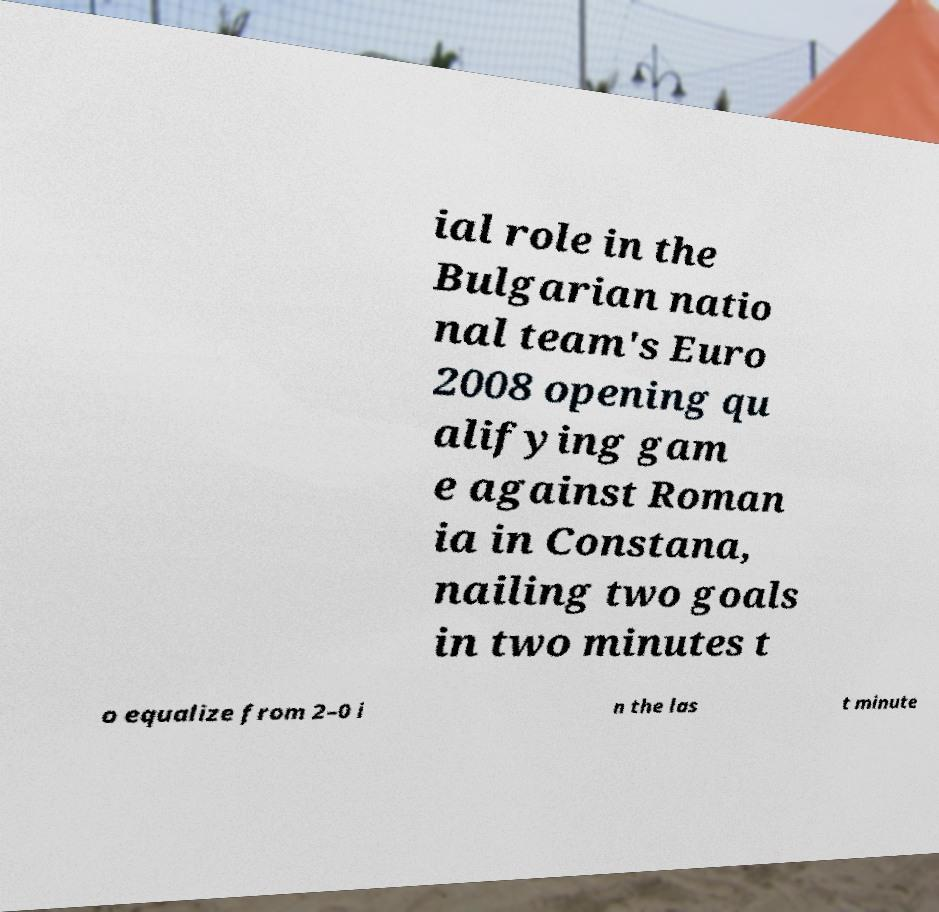Could you extract and type out the text from this image? ial role in the Bulgarian natio nal team's Euro 2008 opening qu alifying gam e against Roman ia in Constana, nailing two goals in two minutes t o equalize from 2–0 i n the las t minute 